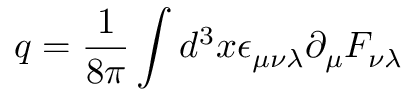Convert formula to latex. <formula><loc_0><loc_0><loc_500><loc_500>q = \frac { 1 } { 8 \pi } \int d ^ { 3 } x \epsilon _ { \mu \nu \lambda } \partial _ { \mu } F _ { \nu \lambda }</formula> 